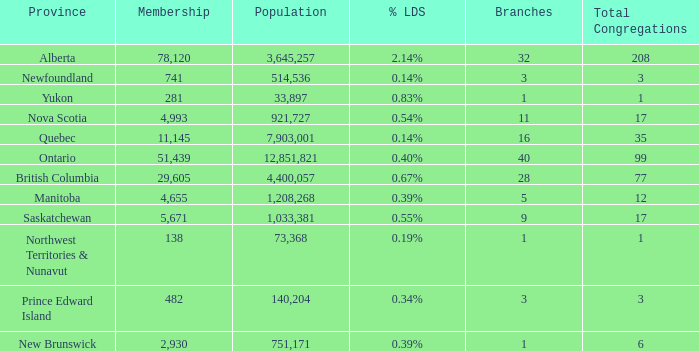What's the sum of population when the membership is 51,439 for fewer than 40 branches? None. 